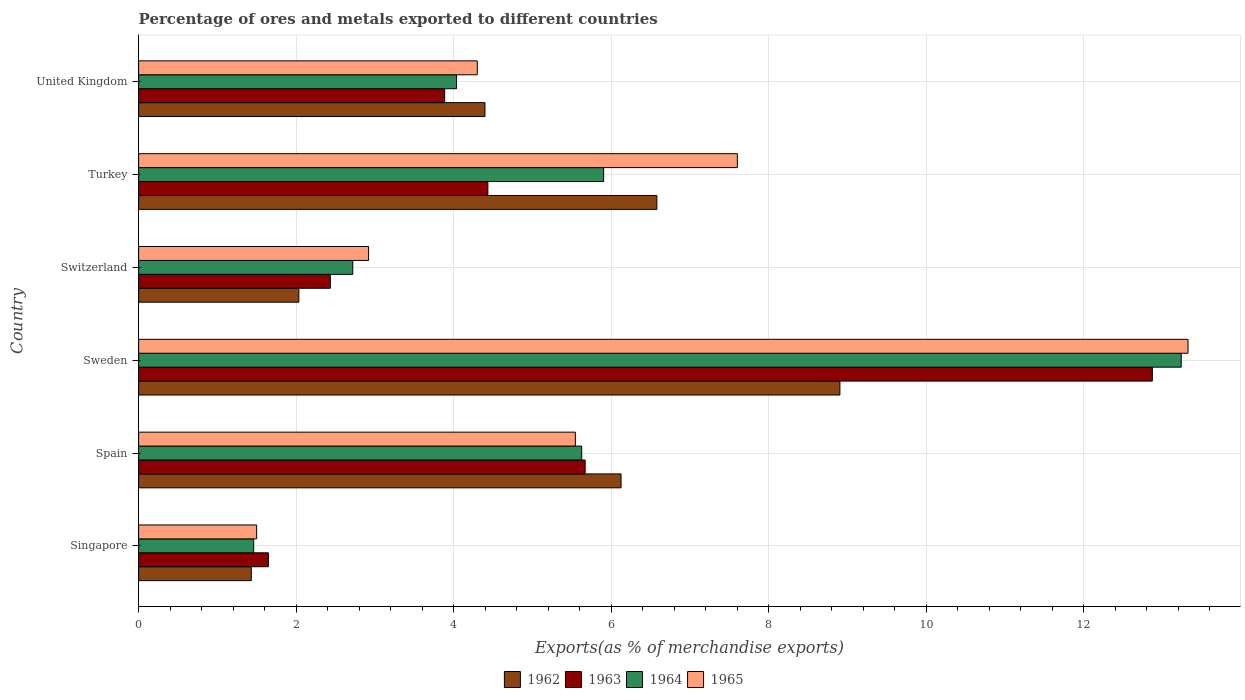How many different coloured bars are there?
Offer a terse response. 4. Are the number of bars per tick equal to the number of legend labels?
Provide a short and direct response. Yes. Are the number of bars on each tick of the Y-axis equal?
Your response must be concise. Yes. How many bars are there on the 1st tick from the top?
Keep it short and to the point. 4. How many bars are there on the 2nd tick from the bottom?
Provide a short and direct response. 4. What is the label of the 3rd group of bars from the top?
Ensure brevity in your answer.  Switzerland. In how many cases, is the number of bars for a given country not equal to the number of legend labels?
Give a very brief answer. 0. What is the percentage of exports to different countries in 1965 in Singapore?
Provide a short and direct response. 1.5. Across all countries, what is the maximum percentage of exports to different countries in 1964?
Provide a short and direct response. 13.24. Across all countries, what is the minimum percentage of exports to different countries in 1965?
Offer a very short reply. 1.5. In which country was the percentage of exports to different countries in 1963 maximum?
Provide a short and direct response. Sweden. In which country was the percentage of exports to different countries in 1963 minimum?
Offer a terse response. Singapore. What is the total percentage of exports to different countries in 1965 in the graph?
Give a very brief answer. 35.19. What is the difference between the percentage of exports to different countries in 1962 in Sweden and that in Turkey?
Your response must be concise. 2.32. What is the difference between the percentage of exports to different countries in 1962 in Sweden and the percentage of exports to different countries in 1963 in Spain?
Provide a short and direct response. 3.23. What is the average percentage of exports to different countries in 1965 per country?
Offer a very short reply. 5.86. What is the difference between the percentage of exports to different countries in 1965 and percentage of exports to different countries in 1962 in Spain?
Your answer should be very brief. -0.58. In how many countries, is the percentage of exports to different countries in 1963 greater than 2.4 %?
Your answer should be very brief. 5. What is the ratio of the percentage of exports to different countries in 1962 in Spain to that in Sweden?
Provide a short and direct response. 0.69. Is the percentage of exports to different countries in 1964 in Sweden less than that in Turkey?
Keep it short and to the point. No. What is the difference between the highest and the second highest percentage of exports to different countries in 1964?
Make the answer very short. 7.33. What is the difference between the highest and the lowest percentage of exports to different countries in 1965?
Provide a short and direct response. 11.83. In how many countries, is the percentage of exports to different countries in 1964 greater than the average percentage of exports to different countries in 1964 taken over all countries?
Your answer should be compact. 3. Is the sum of the percentage of exports to different countries in 1963 in Sweden and United Kingdom greater than the maximum percentage of exports to different countries in 1965 across all countries?
Give a very brief answer. Yes. Is it the case that in every country, the sum of the percentage of exports to different countries in 1965 and percentage of exports to different countries in 1963 is greater than the sum of percentage of exports to different countries in 1964 and percentage of exports to different countries in 1962?
Offer a terse response. No. What does the 3rd bar from the top in Singapore represents?
Keep it short and to the point. 1963. How many bars are there?
Keep it short and to the point. 24. Are all the bars in the graph horizontal?
Provide a succinct answer. Yes. How many countries are there in the graph?
Ensure brevity in your answer.  6. Does the graph contain any zero values?
Ensure brevity in your answer.  No. Does the graph contain grids?
Your answer should be compact. Yes. What is the title of the graph?
Your answer should be very brief. Percentage of ores and metals exported to different countries. What is the label or title of the X-axis?
Give a very brief answer. Exports(as % of merchandise exports). What is the label or title of the Y-axis?
Provide a short and direct response. Country. What is the Exports(as % of merchandise exports) of 1962 in Singapore?
Provide a short and direct response. 1.43. What is the Exports(as % of merchandise exports) in 1963 in Singapore?
Your answer should be very brief. 1.65. What is the Exports(as % of merchandise exports) of 1964 in Singapore?
Make the answer very short. 1.46. What is the Exports(as % of merchandise exports) of 1965 in Singapore?
Your response must be concise. 1.5. What is the Exports(as % of merchandise exports) in 1962 in Spain?
Ensure brevity in your answer.  6.13. What is the Exports(as % of merchandise exports) of 1963 in Spain?
Provide a succinct answer. 5.67. What is the Exports(as % of merchandise exports) of 1964 in Spain?
Keep it short and to the point. 5.63. What is the Exports(as % of merchandise exports) of 1965 in Spain?
Ensure brevity in your answer.  5.55. What is the Exports(as % of merchandise exports) in 1962 in Sweden?
Your answer should be compact. 8.9. What is the Exports(as % of merchandise exports) in 1963 in Sweden?
Offer a terse response. 12.87. What is the Exports(as % of merchandise exports) in 1964 in Sweden?
Your answer should be very brief. 13.24. What is the Exports(as % of merchandise exports) of 1965 in Sweden?
Your answer should be compact. 13.32. What is the Exports(as % of merchandise exports) of 1962 in Switzerland?
Give a very brief answer. 2.03. What is the Exports(as % of merchandise exports) of 1963 in Switzerland?
Your answer should be very brief. 2.43. What is the Exports(as % of merchandise exports) in 1964 in Switzerland?
Provide a succinct answer. 2.72. What is the Exports(as % of merchandise exports) of 1965 in Switzerland?
Provide a succinct answer. 2.92. What is the Exports(as % of merchandise exports) in 1962 in Turkey?
Give a very brief answer. 6.58. What is the Exports(as % of merchandise exports) in 1963 in Turkey?
Provide a succinct answer. 4.43. What is the Exports(as % of merchandise exports) in 1964 in Turkey?
Your answer should be very brief. 5.9. What is the Exports(as % of merchandise exports) of 1965 in Turkey?
Ensure brevity in your answer.  7.6. What is the Exports(as % of merchandise exports) of 1962 in United Kingdom?
Provide a succinct answer. 4.4. What is the Exports(as % of merchandise exports) in 1963 in United Kingdom?
Your response must be concise. 3.89. What is the Exports(as % of merchandise exports) of 1964 in United Kingdom?
Your response must be concise. 4.04. What is the Exports(as % of merchandise exports) in 1965 in United Kingdom?
Give a very brief answer. 4.3. Across all countries, what is the maximum Exports(as % of merchandise exports) in 1962?
Your response must be concise. 8.9. Across all countries, what is the maximum Exports(as % of merchandise exports) in 1963?
Ensure brevity in your answer.  12.87. Across all countries, what is the maximum Exports(as % of merchandise exports) in 1964?
Keep it short and to the point. 13.24. Across all countries, what is the maximum Exports(as % of merchandise exports) in 1965?
Give a very brief answer. 13.32. Across all countries, what is the minimum Exports(as % of merchandise exports) of 1962?
Make the answer very short. 1.43. Across all countries, what is the minimum Exports(as % of merchandise exports) in 1963?
Your answer should be compact. 1.65. Across all countries, what is the minimum Exports(as % of merchandise exports) in 1964?
Your answer should be compact. 1.46. Across all countries, what is the minimum Exports(as % of merchandise exports) in 1965?
Ensure brevity in your answer.  1.5. What is the total Exports(as % of merchandise exports) in 1962 in the graph?
Give a very brief answer. 29.47. What is the total Exports(as % of merchandise exports) of 1963 in the graph?
Keep it short and to the point. 30.94. What is the total Exports(as % of merchandise exports) of 1964 in the graph?
Your response must be concise. 32.98. What is the total Exports(as % of merchandise exports) in 1965 in the graph?
Your answer should be very brief. 35.19. What is the difference between the Exports(as % of merchandise exports) of 1962 in Singapore and that in Spain?
Keep it short and to the point. -4.69. What is the difference between the Exports(as % of merchandise exports) in 1963 in Singapore and that in Spain?
Ensure brevity in your answer.  -4.02. What is the difference between the Exports(as % of merchandise exports) in 1964 in Singapore and that in Spain?
Provide a succinct answer. -4.16. What is the difference between the Exports(as % of merchandise exports) in 1965 in Singapore and that in Spain?
Give a very brief answer. -4.05. What is the difference between the Exports(as % of merchandise exports) in 1962 in Singapore and that in Sweden?
Your response must be concise. -7.47. What is the difference between the Exports(as % of merchandise exports) of 1963 in Singapore and that in Sweden?
Give a very brief answer. -11.22. What is the difference between the Exports(as % of merchandise exports) of 1964 in Singapore and that in Sweden?
Offer a very short reply. -11.78. What is the difference between the Exports(as % of merchandise exports) of 1965 in Singapore and that in Sweden?
Make the answer very short. -11.83. What is the difference between the Exports(as % of merchandise exports) of 1962 in Singapore and that in Switzerland?
Make the answer very short. -0.6. What is the difference between the Exports(as % of merchandise exports) of 1963 in Singapore and that in Switzerland?
Your answer should be compact. -0.79. What is the difference between the Exports(as % of merchandise exports) of 1964 in Singapore and that in Switzerland?
Make the answer very short. -1.26. What is the difference between the Exports(as % of merchandise exports) of 1965 in Singapore and that in Switzerland?
Your answer should be very brief. -1.42. What is the difference between the Exports(as % of merchandise exports) of 1962 in Singapore and that in Turkey?
Offer a terse response. -5.15. What is the difference between the Exports(as % of merchandise exports) of 1963 in Singapore and that in Turkey?
Make the answer very short. -2.79. What is the difference between the Exports(as % of merchandise exports) of 1964 in Singapore and that in Turkey?
Your answer should be compact. -4.44. What is the difference between the Exports(as % of merchandise exports) of 1965 in Singapore and that in Turkey?
Provide a succinct answer. -6.1. What is the difference between the Exports(as % of merchandise exports) of 1962 in Singapore and that in United Kingdom?
Make the answer very short. -2.97. What is the difference between the Exports(as % of merchandise exports) of 1963 in Singapore and that in United Kingdom?
Make the answer very short. -2.24. What is the difference between the Exports(as % of merchandise exports) of 1964 in Singapore and that in United Kingdom?
Make the answer very short. -2.58. What is the difference between the Exports(as % of merchandise exports) in 1965 in Singapore and that in United Kingdom?
Offer a very short reply. -2.8. What is the difference between the Exports(as % of merchandise exports) in 1962 in Spain and that in Sweden?
Keep it short and to the point. -2.78. What is the difference between the Exports(as % of merchandise exports) in 1963 in Spain and that in Sweden?
Your response must be concise. -7.2. What is the difference between the Exports(as % of merchandise exports) of 1964 in Spain and that in Sweden?
Keep it short and to the point. -7.61. What is the difference between the Exports(as % of merchandise exports) in 1965 in Spain and that in Sweden?
Keep it short and to the point. -7.78. What is the difference between the Exports(as % of merchandise exports) of 1962 in Spain and that in Switzerland?
Make the answer very short. 4.09. What is the difference between the Exports(as % of merchandise exports) in 1963 in Spain and that in Switzerland?
Ensure brevity in your answer.  3.24. What is the difference between the Exports(as % of merchandise exports) in 1964 in Spain and that in Switzerland?
Offer a terse response. 2.91. What is the difference between the Exports(as % of merchandise exports) of 1965 in Spain and that in Switzerland?
Offer a very short reply. 2.63. What is the difference between the Exports(as % of merchandise exports) of 1962 in Spain and that in Turkey?
Give a very brief answer. -0.46. What is the difference between the Exports(as % of merchandise exports) of 1963 in Spain and that in Turkey?
Keep it short and to the point. 1.23. What is the difference between the Exports(as % of merchandise exports) of 1964 in Spain and that in Turkey?
Your answer should be very brief. -0.28. What is the difference between the Exports(as % of merchandise exports) in 1965 in Spain and that in Turkey?
Your answer should be compact. -2.06. What is the difference between the Exports(as % of merchandise exports) of 1962 in Spain and that in United Kingdom?
Keep it short and to the point. 1.73. What is the difference between the Exports(as % of merchandise exports) in 1963 in Spain and that in United Kingdom?
Your answer should be compact. 1.78. What is the difference between the Exports(as % of merchandise exports) in 1964 in Spain and that in United Kingdom?
Ensure brevity in your answer.  1.59. What is the difference between the Exports(as % of merchandise exports) of 1965 in Spain and that in United Kingdom?
Offer a terse response. 1.25. What is the difference between the Exports(as % of merchandise exports) in 1962 in Sweden and that in Switzerland?
Provide a short and direct response. 6.87. What is the difference between the Exports(as % of merchandise exports) of 1963 in Sweden and that in Switzerland?
Give a very brief answer. 10.44. What is the difference between the Exports(as % of merchandise exports) in 1964 in Sweden and that in Switzerland?
Give a very brief answer. 10.52. What is the difference between the Exports(as % of merchandise exports) in 1965 in Sweden and that in Switzerland?
Ensure brevity in your answer.  10.4. What is the difference between the Exports(as % of merchandise exports) of 1962 in Sweden and that in Turkey?
Offer a terse response. 2.32. What is the difference between the Exports(as % of merchandise exports) in 1963 in Sweden and that in Turkey?
Provide a short and direct response. 8.44. What is the difference between the Exports(as % of merchandise exports) in 1964 in Sweden and that in Turkey?
Offer a terse response. 7.33. What is the difference between the Exports(as % of merchandise exports) in 1965 in Sweden and that in Turkey?
Offer a very short reply. 5.72. What is the difference between the Exports(as % of merchandise exports) in 1962 in Sweden and that in United Kingdom?
Offer a very short reply. 4.51. What is the difference between the Exports(as % of merchandise exports) of 1963 in Sweden and that in United Kingdom?
Your answer should be very brief. 8.99. What is the difference between the Exports(as % of merchandise exports) in 1964 in Sweden and that in United Kingdom?
Offer a very short reply. 9.2. What is the difference between the Exports(as % of merchandise exports) of 1965 in Sweden and that in United Kingdom?
Offer a very short reply. 9.02. What is the difference between the Exports(as % of merchandise exports) of 1962 in Switzerland and that in Turkey?
Ensure brevity in your answer.  -4.55. What is the difference between the Exports(as % of merchandise exports) in 1963 in Switzerland and that in Turkey?
Offer a terse response. -2. What is the difference between the Exports(as % of merchandise exports) of 1964 in Switzerland and that in Turkey?
Make the answer very short. -3.19. What is the difference between the Exports(as % of merchandise exports) of 1965 in Switzerland and that in Turkey?
Your response must be concise. -4.68. What is the difference between the Exports(as % of merchandise exports) of 1962 in Switzerland and that in United Kingdom?
Provide a succinct answer. -2.36. What is the difference between the Exports(as % of merchandise exports) in 1963 in Switzerland and that in United Kingdom?
Offer a very short reply. -1.45. What is the difference between the Exports(as % of merchandise exports) in 1964 in Switzerland and that in United Kingdom?
Make the answer very short. -1.32. What is the difference between the Exports(as % of merchandise exports) of 1965 in Switzerland and that in United Kingdom?
Provide a short and direct response. -1.38. What is the difference between the Exports(as % of merchandise exports) in 1962 in Turkey and that in United Kingdom?
Offer a terse response. 2.18. What is the difference between the Exports(as % of merchandise exports) of 1963 in Turkey and that in United Kingdom?
Your answer should be compact. 0.55. What is the difference between the Exports(as % of merchandise exports) of 1964 in Turkey and that in United Kingdom?
Give a very brief answer. 1.87. What is the difference between the Exports(as % of merchandise exports) in 1965 in Turkey and that in United Kingdom?
Offer a terse response. 3.3. What is the difference between the Exports(as % of merchandise exports) of 1962 in Singapore and the Exports(as % of merchandise exports) of 1963 in Spain?
Offer a very short reply. -4.24. What is the difference between the Exports(as % of merchandise exports) of 1962 in Singapore and the Exports(as % of merchandise exports) of 1964 in Spain?
Ensure brevity in your answer.  -4.2. What is the difference between the Exports(as % of merchandise exports) of 1962 in Singapore and the Exports(as % of merchandise exports) of 1965 in Spain?
Keep it short and to the point. -4.11. What is the difference between the Exports(as % of merchandise exports) of 1963 in Singapore and the Exports(as % of merchandise exports) of 1964 in Spain?
Provide a succinct answer. -3.98. What is the difference between the Exports(as % of merchandise exports) of 1963 in Singapore and the Exports(as % of merchandise exports) of 1965 in Spain?
Offer a terse response. -3.9. What is the difference between the Exports(as % of merchandise exports) of 1964 in Singapore and the Exports(as % of merchandise exports) of 1965 in Spain?
Your answer should be very brief. -4.08. What is the difference between the Exports(as % of merchandise exports) in 1962 in Singapore and the Exports(as % of merchandise exports) in 1963 in Sweden?
Provide a short and direct response. -11.44. What is the difference between the Exports(as % of merchandise exports) in 1962 in Singapore and the Exports(as % of merchandise exports) in 1964 in Sweden?
Provide a succinct answer. -11.81. What is the difference between the Exports(as % of merchandise exports) in 1962 in Singapore and the Exports(as % of merchandise exports) in 1965 in Sweden?
Ensure brevity in your answer.  -11.89. What is the difference between the Exports(as % of merchandise exports) of 1963 in Singapore and the Exports(as % of merchandise exports) of 1964 in Sweden?
Ensure brevity in your answer.  -11.59. What is the difference between the Exports(as % of merchandise exports) of 1963 in Singapore and the Exports(as % of merchandise exports) of 1965 in Sweden?
Your answer should be very brief. -11.68. What is the difference between the Exports(as % of merchandise exports) of 1964 in Singapore and the Exports(as % of merchandise exports) of 1965 in Sweden?
Your answer should be compact. -11.86. What is the difference between the Exports(as % of merchandise exports) in 1962 in Singapore and the Exports(as % of merchandise exports) in 1963 in Switzerland?
Offer a terse response. -1. What is the difference between the Exports(as % of merchandise exports) of 1962 in Singapore and the Exports(as % of merchandise exports) of 1964 in Switzerland?
Offer a terse response. -1.29. What is the difference between the Exports(as % of merchandise exports) of 1962 in Singapore and the Exports(as % of merchandise exports) of 1965 in Switzerland?
Provide a succinct answer. -1.49. What is the difference between the Exports(as % of merchandise exports) of 1963 in Singapore and the Exports(as % of merchandise exports) of 1964 in Switzerland?
Your response must be concise. -1.07. What is the difference between the Exports(as % of merchandise exports) of 1963 in Singapore and the Exports(as % of merchandise exports) of 1965 in Switzerland?
Offer a very short reply. -1.27. What is the difference between the Exports(as % of merchandise exports) of 1964 in Singapore and the Exports(as % of merchandise exports) of 1965 in Switzerland?
Provide a succinct answer. -1.46. What is the difference between the Exports(as % of merchandise exports) of 1962 in Singapore and the Exports(as % of merchandise exports) of 1963 in Turkey?
Offer a terse response. -3. What is the difference between the Exports(as % of merchandise exports) of 1962 in Singapore and the Exports(as % of merchandise exports) of 1964 in Turkey?
Provide a succinct answer. -4.47. What is the difference between the Exports(as % of merchandise exports) of 1962 in Singapore and the Exports(as % of merchandise exports) of 1965 in Turkey?
Provide a short and direct response. -6.17. What is the difference between the Exports(as % of merchandise exports) of 1963 in Singapore and the Exports(as % of merchandise exports) of 1964 in Turkey?
Provide a succinct answer. -4.26. What is the difference between the Exports(as % of merchandise exports) in 1963 in Singapore and the Exports(as % of merchandise exports) in 1965 in Turkey?
Offer a very short reply. -5.95. What is the difference between the Exports(as % of merchandise exports) of 1964 in Singapore and the Exports(as % of merchandise exports) of 1965 in Turkey?
Provide a succinct answer. -6.14. What is the difference between the Exports(as % of merchandise exports) of 1962 in Singapore and the Exports(as % of merchandise exports) of 1963 in United Kingdom?
Your answer should be compact. -2.46. What is the difference between the Exports(as % of merchandise exports) in 1962 in Singapore and the Exports(as % of merchandise exports) in 1964 in United Kingdom?
Give a very brief answer. -2.61. What is the difference between the Exports(as % of merchandise exports) of 1962 in Singapore and the Exports(as % of merchandise exports) of 1965 in United Kingdom?
Provide a succinct answer. -2.87. What is the difference between the Exports(as % of merchandise exports) of 1963 in Singapore and the Exports(as % of merchandise exports) of 1964 in United Kingdom?
Offer a very short reply. -2.39. What is the difference between the Exports(as % of merchandise exports) of 1963 in Singapore and the Exports(as % of merchandise exports) of 1965 in United Kingdom?
Provide a succinct answer. -2.65. What is the difference between the Exports(as % of merchandise exports) of 1964 in Singapore and the Exports(as % of merchandise exports) of 1965 in United Kingdom?
Keep it short and to the point. -2.84. What is the difference between the Exports(as % of merchandise exports) of 1962 in Spain and the Exports(as % of merchandise exports) of 1963 in Sweden?
Offer a terse response. -6.75. What is the difference between the Exports(as % of merchandise exports) in 1962 in Spain and the Exports(as % of merchandise exports) in 1964 in Sweden?
Keep it short and to the point. -7.11. What is the difference between the Exports(as % of merchandise exports) in 1962 in Spain and the Exports(as % of merchandise exports) in 1965 in Sweden?
Keep it short and to the point. -7.2. What is the difference between the Exports(as % of merchandise exports) of 1963 in Spain and the Exports(as % of merchandise exports) of 1964 in Sweden?
Provide a succinct answer. -7.57. What is the difference between the Exports(as % of merchandise exports) in 1963 in Spain and the Exports(as % of merchandise exports) in 1965 in Sweden?
Ensure brevity in your answer.  -7.65. What is the difference between the Exports(as % of merchandise exports) in 1964 in Spain and the Exports(as % of merchandise exports) in 1965 in Sweden?
Provide a short and direct response. -7.7. What is the difference between the Exports(as % of merchandise exports) of 1962 in Spain and the Exports(as % of merchandise exports) of 1963 in Switzerland?
Make the answer very short. 3.69. What is the difference between the Exports(as % of merchandise exports) in 1962 in Spain and the Exports(as % of merchandise exports) in 1964 in Switzerland?
Your answer should be compact. 3.41. What is the difference between the Exports(as % of merchandise exports) of 1962 in Spain and the Exports(as % of merchandise exports) of 1965 in Switzerland?
Provide a short and direct response. 3.21. What is the difference between the Exports(as % of merchandise exports) of 1963 in Spain and the Exports(as % of merchandise exports) of 1964 in Switzerland?
Your answer should be compact. 2.95. What is the difference between the Exports(as % of merchandise exports) in 1963 in Spain and the Exports(as % of merchandise exports) in 1965 in Switzerland?
Provide a succinct answer. 2.75. What is the difference between the Exports(as % of merchandise exports) of 1964 in Spain and the Exports(as % of merchandise exports) of 1965 in Switzerland?
Offer a terse response. 2.71. What is the difference between the Exports(as % of merchandise exports) of 1962 in Spain and the Exports(as % of merchandise exports) of 1963 in Turkey?
Your answer should be compact. 1.69. What is the difference between the Exports(as % of merchandise exports) of 1962 in Spain and the Exports(as % of merchandise exports) of 1964 in Turkey?
Provide a succinct answer. 0.22. What is the difference between the Exports(as % of merchandise exports) in 1962 in Spain and the Exports(as % of merchandise exports) in 1965 in Turkey?
Ensure brevity in your answer.  -1.48. What is the difference between the Exports(as % of merchandise exports) in 1963 in Spain and the Exports(as % of merchandise exports) in 1964 in Turkey?
Provide a succinct answer. -0.23. What is the difference between the Exports(as % of merchandise exports) in 1963 in Spain and the Exports(as % of merchandise exports) in 1965 in Turkey?
Give a very brief answer. -1.93. What is the difference between the Exports(as % of merchandise exports) of 1964 in Spain and the Exports(as % of merchandise exports) of 1965 in Turkey?
Provide a succinct answer. -1.98. What is the difference between the Exports(as % of merchandise exports) in 1962 in Spain and the Exports(as % of merchandise exports) in 1963 in United Kingdom?
Your answer should be very brief. 2.24. What is the difference between the Exports(as % of merchandise exports) of 1962 in Spain and the Exports(as % of merchandise exports) of 1964 in United Kingdom?
Ensure brevity in your answer.  2.09. What is the difference between the Exports(as % of merchandise exports) of 1962 in Spain and the Exports(as % of merchandise exports) of 1965 in United Kingdom?
Offer a very short reply. 1.83. What is the difference between the Exports(as % of merchandise exports) in 1963 in Spain and the Exports(as % of merchandise exports) in 1964 in United Kingdom?
Your answer should be compact. 1.63. What is the difference between the Exports(as % of merchandise exports) in 1963 in Spain and the Exports(as % of merchandise exports) in 1965 in United Kingdom?
Provide a succinct answer. 1.37. What is the difference between the Exports(as % of merchandise exports) of 1964 in Spain and the Exports(as % of merchandise exports) of 1965 in United Kingdom?
Your answer should be very brief. 1.33. What is the difference between the Exports(as % of merchandise exports) in 1962 in Sweden and the Exports(as % of merchandise exports) in 1963 in Switzerland?
Your answer should be very brief. 6.47. What is the difference between the Exports(as % of merchandise exports) in 1962 in Sweden and the Exports(as % of merchandise exports) in 1964 in Switzerland?
Offer a very short reply. 6.18. What is the difference between the Exports(as % of merchandise exports) of 1962 in Sweden and the Exports(as % of merchandise exports) of 1965 in Switzerland?
Make the answer very short. 5.98. What is the difference between the Exports(as % of merchandise exports) in 1963 in Sweden and the Exports(as % of merchandise exports) in 1964 in Switzerland?
Offer a very short reply. 10.15. What is the difference between the Exports(as % of merchandise exports) of 1963 in Sweden and the Exports(as % of merchandise exports) of 1965 in Switzerland?
Offer a terse response. 9.95. What is the difference between the Exports(as % of merchandise exports) in 1964 in Sweden and the Exports(as % of merchandise exports) in 1965 in Switzerland?
Offer a terse response. 10.32. What is the difference between the Exports(as % of merchandise exports) of 1962 in Sweden and the Exports(as % of merchandise exports) of 1963 in Turkey?
Keep it short and to the point. 4.47. What is the difference between the Exports(as % of merchandise exports) of 1962 in Sweden and the Exports(as % of merchandise exports) of 1964 in Turkey?
Your answer should be compact. 3. What is the difference between the Exports(as % of merchandise exports) of 1962 in Sweden and the Exports(as % of merchandise exports) of 1965 in Turkey?
Provide a succinct answer. 1.3. What is the difference between the Exports(as % of merchandise exports) of 1963 in Sweden and the Exports(as % of merchandise exports) of 1964 in Turkey?
Give a very brief answer. 6.97. What is the difference between the Exports(as % of merchandise exports) in 1963 in Sweden and the Exports(as % of merchandise exports) in 1965 in Turkey?
Ensure brevity in your answer.  5.27. What is the difference between the Exports(as % of merchandise exports) of 1964 in Sweden and the Exports(as % of merchandise exports) of 1965 in Turkey?
Offer a very short reply. 5.64. What is the difference between the Exports(as % of merchandise exports) in 1962 in Sweden and the Exports(as % of merchandise exports) in 1963 in United Kingdom?
Offer a very short reply. 5.02. What is the difference between the Exports(as % of merchandise exports) in 1962 in Sweden and the Exports(as % of merchandise exports) in 1964 in United Kingdom?
Your answer should be very brief. 4.87. What is the difference between the Exports(as % of merchandise exports) of 1962 in Sweden and the Exports(as % of merchandise exports) of 1965 in United Kingdom?
Your response must be concise. 4.6. What is the difference between the Exports(as % of merchandise exports) of 1963 in Sweden and the Exports(as % of merchandise exports) of 1964 in United Kingdom?
Offer a very short reply. 8.83. What is the difference between the Exports(as % of merchandise exports) of 1963 in Sweden and the Exports(as % of merchandise exports) of 1965 in United Kingdom?
Provide a short and direct response. 8.57. What is the difference between the Exports(as % of merchandise exports) of 1964 in Sweden and the Exports(as % of merchandise exports) of 1965 in United Kingdom?
Offer a terse response. 8.94. What is the difference between the Exports(as % of merchandise exports) in 1962 in Switzerland and the Exports(as % of merchandise exports) in 1963 in Turkey?
Your response must be concise. -2.4. What is the difference between the Exports(as % of merchandise exports) in 1962 in Switzerland and the Exports(as % of merchandise exports) in 1964 in Turkey?
Offer a terse response. -3.87. What is the difference between the Exports(as % of merchandise exports) in 1962 in Switzerland and the Exports(as % of merchandise exports) in 1965 in Turkey?
Ensure brevity in your answer.  -5.57. What is the difference between the Exports(as % of merchandise exports) in 1963 in Switzerland and the Exports(as % of merchandise exports) in 1964 in Turkey?
Provide a short and direct response. -3.47. What is the difference between the Exports(as % of merchandise exports) in 1963 in Switzerland and the Exports(as % of merchandise exports) in 1965 in Turkey?
Provide a short and direct response. -5.17. What is the difference between the Exports(as % of merchandise exports) of 1964 in Switzerland and the Exports(as % of merchandise exports) of 1965 in Turkey?
Make the answer very short. -4.88. What is the difference between the Exports(as % of merchandise exports) of 1962 in Switzerland and the Exports(as % of merchandise exports) of 1963 in United Kingdom?
Your response must be concise. -1.85. What is the difference between the Exports(as % of merchandise exports) in 1962 in Switzerland and the Exports(as % of merchandise exports) in 1964 in United Kingdom?
Make the answer very short. -2. What is the difference between the Exports(as % of merchandise exports) of 1962 in Switzerland and the Exports(as % of merchandise exports) of 1965 in United Kingdom?
Provide a succinct answer. -2.27. What is the difference between the Exports(as % of merchandise exports) of 1963 in Switzerland and the Exports(as % of merchandise exports) of 1964 in United Kingdom?
Offer a terse response. -1.6. What is the difference between the Exports(as % of merchandise exports) in 1963 in Switzerland and the Exports(as % of merchandise exports) in 1965 in United Kingdom?
Ensure brevity in your answer.  -1.87. What is the difference between the Exports(as % of merchandise exports) in 1964 in Switzerland and the Exports(as % of merchandise exports) in 1965 in United Kingdom?
Your answer should be very brief. -1.58. What is the difference between the Exports(as % of merchandise exports) of 1962 in Turkey and the Exports(as % of merchandise exports) of 1963 in United Kingdom?
Your answer should be compact. 2.69. What is the difference between the Exports(as % of merchandise exports) in 1962 in Turkey and the Exports(as % of merchandise exports) in 1964 in United Kingdom?
Your answer should be very brief. 2.54. What is the difference between the Exports(as % of merchandise exports) in 1962 in Turkey and the Exports(as % of merchandise exports) in 1965 in United Kingdom?
Offer a terse response. 2.28. What is the difference between the Exports(as % of merchandise exports) of 1963 in Turkey and the Exports(as % of merchandise exports) of 1964 in United Kingdom?
Your answer should be very brief. 0.4. What is the difference between the Exports(as % of merchandise exports) in 1963 in Turkey and the Exports(as % of merchandise exports) in 1965 in United Kingdom?
Your response must be concise. 0.13. What is the difference between the Exports(as % of merchandise exports) in 1964 in Turkey and the Exports(as % of merchandise exports) in 1965 in United Kingdom?
Offer a terse response. 1.6. What is the average Exports(as % of merchandise exports) in 1962 per country?
Give a very brief answer. 4.91. What is the average Exports(as % of merchandise exports) of 1963 per country?
Keep it short and to the point. 5.16. What is the average Exports(as % of merchandise exports) of 1964 per country?
Ensure brevity in your answer.  5.5. What is the average Exports(as % of merchandise exports) of 1965 per country?
Your answer should be compact. 5.86. What is the difference between the Exports(as % of merchandise exports) in 1962 and Exports(as % of merchandise exports) in 1963 in Singapore?
Provide a short and direct response. -0.22. What is the difference between the Exports(as % of merchandise exports) of 1962 and Exports(as % of merchandise exports) of 1964 in Singapore?
Your response must be concise. -0.03. What is the difference between the Exports(as % of merchandise exports) in 1962 and Exports(as % of merchandise exports) in 1965 in Singapore?
Give a very brief answer. -0.07. What is the difference between the Exports(as % of merchandise exports) of 1963 and Exports(as % of merchandise exports) of 1964 in Singapore?
Provide a succinct answer. 0.19. What is the difference between the Exports(as % of merchandise exports) of 1963 and Exports(as % of merchandise exports) of 1965 in Singapore?
Offer a terse response. 0.15. What is the difference between the Exports(as % of merchandise exports) in 1964 and Exports(as % of merchandise exports) in 1965 in Singapore?
Offer a very short reply. -0.04. What is the difference between the Exports(as % of merchandise exports) in 1962 and Exports(as % of merchandise exports) in 1963 in Spain?
Offer a terse response. 0.46. What is the difference between the Exports(as % of merchandise exports) in 1962 and Exports(as % of merchandise exports) in 1964 in Spain?
Offer a very short reply. 0.5. What is the difference between the Exports(as % of merchandise exports) in 1962 and Exports(as % of merchandise exports) in 1965 in Spain?
Offer a terse response. 0.58. What is the difference between the Exports(as % of merchandise exports) of 1963 and Exports(as % of merchandise exports) of 1964 in Spain?
Ensure brevity in your answer.  0.04. What is the difference between the Exports(as % of merchandise exports) of 1963 and Exports(as % of merchandise exports) of 1965 in Spain?
Your answer should be very brief. 0.12. What is the difference between the Exports(as % of merchandise exports) of 1964 and Exports(as % of merchandise exports) of 1965 in Spain?
Your response must be concise. 0.08. What is the difference between the Exports(as % of merchandise exports) in 1962 and Exports(as % of merchandise exports) in 1963 in Sweden?
Keep it short and to the point. -3.97. What is the difference between the Exports(as % of merchandise exports) in 1962 and Exports(as % of merchandise exports) in 1964 in Sweden?
Make the answer very short. -4.33. What is the difference between the Exports(as % of merchandise exports) in 1962 and Exports(as % of merchandise exports) in 1965 in Sweden?
Give a very brief answer. -4.42. What is the difference between the Exports(as % of merchandise exports) in 1963 and Exports(as % of merchandise exports) in 1964 in Sweden?
Provide a succinct answer. -0.37. What is the difference between the Exports(as % of merchandise exports) of 1963 and Exports(as % of merchandise exports) of 1965 in Sweden?
Ensure brevity in your answer.  -0.45. What is the difference between the Exports(as % of merchandise exports) of 1964 and Exports(as % of merchandise exports) of 1965 in Sweden?
Give a very brief answer. -0.09. What is the difference between the Exports(as % of merchandise exports) of 1962 and Exports(as % of merchandise exports) of 1963 in Switzerland?
Make the answer very short. -0.4. What is the difference between the Exports(as % of merchandise exports) of 1962 and Exports(as % of merchandise exports) of 1964 in Switzerland?
Offer a terse response. -0.68. What is the difference between the Exports(as % of merchandise exports) in 1962 and Exports(as % of merchandise exports) in 1965 in Switzerland?
Your answer should be very brief. -0.89. What is the difference between the Exports(as % of merchandise exports) of 1963 and Exports(as % of merchandise exports) of 1964 in Switzerland?
Provide a succinct answer. -0.29. What is the difference between the Exports(as % of merchandise exports) of 1963 and Exports(as % of merchandise exports) of 1965 in Switzerland?
Give a very brief answer. -0.49. What is the difference between the Exports(as % of merchandise exports) in 1964 and Exports(as % of merchandise exports) in 1965 in Switzerland?
Your answer should be very brief. -0.2. What is the difference between the Exports(as % of merchandise exports) in 1962 and Exports(as % of merchandise exports) in 1963 in Turkey?
Your answer should be compact. 2.15. What is the difference between the Exports(as % of merchandise exports) of 1962 and Exports(as % of merchandise exports) of 1964 in Turkey?
Give a very brief answer. 0.68. What is the difference between the Exports(as % of merchandise exports) in 1962 and Exports(as % of merchandise exports) in 1965 in Turkey?
Your answer should be compact. -1.02. What is the difference between the Exports(as % of merchandise exports) of 1963 and Exports(as % of merchandise exports) of 1964 in Turkey?
Provide a short and direct response. -1.47. What is the difference between the Exports(as % of merchandise exports) of 1963 and Exports(as % of merchandise exports) of 1965 in Turkey?
Offer a very short reply. -3.17. What is the difference between the Exports(as % of merchandise exports) of 1964 and Exports(as % of merchandise exports) of 1965 in Turkey?
Provide a short and direct response. -1.7. What is the difference between the Exports(as % of merchandise exports) of 1962 and Exports(as % of merchandise exports) of 1963 in United Kingdom?
Ensure brevity in your answer.  0.51. What is the difference between the Exports(as % of merchandise exports) of 1962 and Exports(as % of merchandise exports) of 1964 in United Kingdom?
Give a very brief answer. 0.36. What is the difference between the Exports(as % of merchandise exports) in 1962 and Exports(as % of merchandise exports) in 1965 in United Kingdom?
Give a very brief answer. 0.1. What is the difference between the Exports(as % of merchandise exports) of 1963 and Exports(as % of merchandise exports) of 1964 in United Kingdom?
Give a very brief answer. -0.15. What is the difference between the Exports(as % of merchandise exports) in 1963 and Exports(as % of merchandise exports) in 1965 in United Kingdom?
Ensure brevity in your answer.  -0.41. What is the difference between the Exports(as % of merchandise exports) in 1964 and Exports(as % of merchandise exports) in 1965 in United Kingdom?
Give a very brief answer. -0.26. What is the ratio of the Exports(as % of merchandise exports) of 1962 in Singapore to that in Spain?
Provide a short and direct response. 0.23. What is the ratio of the Exports(as % of merchandise exports) of 1963 in Singapore to that in Spain?
Provide a succinct answer. 0.29. What is the ratio of the Exports(as % of merchandise exports) in 1964 in Singapore to that in Spain?
Make the answer very short. 0.26. What is the ratio of the Exports(as % of merchandise exports) of 1965 in Singapore to that in Spain?
Offer a very short reply. 0.27. What is the ratio of the Exports(as % of merchandise exports) of 1962 in Singapore to that in Sweden?
Provide a short and direct response. 0.16. What is the ratio of the Exports(as % of merchandise exports) in 1963 in Singapore to that in Sweden?
Offer a very short reply. 0.13. What is the ratio of the Exports(as % of merchandise exports) of 1964 in Singapore to that in Sweden?
Provide a succinct answer. 0.11. What is the ratio of the Exports(as % of merchandise exports) of 1965 in Singapore to that in Sweden?
Ensure brevity in your answer.  0.11. What is the ratio of the Exports(as % of merchandise exports) in 1962 in Singapore to that in Switzerland?
Your answer should be very brief. 0.7. What is the ratio of the Exports(as % of merchandise exports) in 1963 in Singapore to that in Switzerland?
Offer a very short reply. 0.68. What is the ratio of the Exports(as % of merchandise exports) in 1964 in Singapore to that in Switzerland?
Provide a succinct answer. 0.54. What is the ratio of the Exports(as % of merchandise exports) of 1965 in Singapore to that in Switzerland?
Offer a terse response. 0.51. What is the ratio of the Exports(as % of merchandise exports) in 1962 in Singapore to that in Turkey?
Ensure brevity in your answer.  0.22. What is the ratio of the Exports(as % of merchandise exports) in 1963 in Singapore to that in Turkey?
Your response must be concise. 0.37. What is the ratio of the Exports(as % of merchandise exports) of 1964 in Singapore to that in Turkey?
Your response must be concise. 0.25. What is the ratio of the Exports(as % of merchandise exports) in 1965 in Singapore to that in Turkey?
Your answer should be compact. 0.2. What is the ratio of the Exports(as % of merchandise exports) of 1962 in Singapore to that in United Kingdom?
Provide a short and direct response. 0.33. What is the ratio of the Exports(as % of merchandise exports) in 1963 in Singapore to that in United Kingdom?
Your response must be concise. 0.42. What is the ratio of the Exports(as % of merchandise exports) in 1964 in Singapore to that in United Kingdom?
Keep it short and to the point. 0.36. What is the ratio of the Exports(as % of merchandise exports) in 1965 in Singapore to that in United Kingdom?
Make the answer very short. 0.35. What is the ratio of the Exports(as % of merchandise exports) in 1962 in Spain to that in Sweden?
Give a very brief answer. 0.69. What is the ratio of the Exports(as % of merchandise exports) of 1963 in Spain to that in Sweden?
Your response must be concise. 0.44. What is the ratio of the Exports(as % of merchandise exports) in 1964 in Spain to that in Sweden?
Make the answer very short. 0.42. What is the ratio of the Exports(as % of merchandise exports) in 1965 in Spain to that in Sweden?
Offer a terse response. 0.42. What is the ratio of the Exports(as % of merchandise exports) of 1962 in Spain to that in Switzerland?
Your answer should be compact. 3.01. What is the ratio of the Exports(as % of merchandise exports) in 1963 in Spain to that in Switzerland?
Keep it short and to the point. 2.33. What is the ratio of the Exports(as % of merchandise exports) in 1964 in Spain to that in Switzerland?
Provide a short and direct response. 2.07. What is the ratio of the Exports(as % of merchandise exports) in 1965 in Spain to that in Switzerland?
Offer a very short reply. 1.9. What is the ratio of the Exports(as % of merchandise exports) in 1962 in Spain to that in Turkey?
Keep it short and to the point. 0.93. What is the ratio of the Exports(as % of merchandise exports) in 1963 in Spain to that in Turkey?
Your answer should be very brief. 1.28. What is the ratio of the Exports(as % of merchandise exports) of 1964 in Spain to that in Turkey?
Your answer should be very brief. 0.95. What is the ratio of the Exports(as % of merchandise exports) in 1965 in Spain to that in Turkey?
Make the answer very short. 0.73. What is the ratio of the Exports(as % of merchandise exports) of 1962 in Spain to that in United Kingdom?
Provide a succinct answer. 1.39. What is the ratio of the Exports(as % of merchandise exports) of 1963 in Spain to that in United Kingdom?
Provide a succinct answer. 1.46. What is the ratio of the Exports(as % of merchandise exports) of 1964 in Spain to that in United Kingdom?
Your answer should be very brief. 1.39. What is the ratio of the Exports(as % of merchandise exports) of 1965 in Spain to that in United Kingdom?
Offer a very short reply. 1.29. What is the ratio of the Exports(as % of merchandise exports) of 1962 in Sweden to that in Switzerland?
Your answer should be compact. 4.38. What is the ratio of the Exports(as % of merchandise exports) of 1963 in Sweden to that in Switzerland?
Your answer should be very brief. 5.29. What is the ratio of the Exports(as % of merchandise exports) of 1964 in Sweden to that in Switzerland?
Your answer should be very brief. 4.87. What is the ratio of the Exports(as % of merchandise exports) of 1965 in Sweden to that in Switzerland?
Your answer should be compact. 4.56. What is the ratio of the Exports(as % of merchandise exports) of 1962 in Sweden to that in Turkey?
Offer a terse response. 1.35. What is the ratio of the Exports(as % of merchandise exports) in 1963 in Sweden to that in Turkey?
Your answer should be compact. 2.9. What is the ratio of the Exports(as % of merchandise exports) of 1964 in Sweden to that in Turkey?
Provide a succinct answer. 2.24. What is the ratio of the Exports(as % of merchandise exports) in 1965 in Sweden to that in Turkey?
Provide a short and direct response. 1.75. What is the ratio of the Exports(as % of merchandise exports) in 1962 in Sweden to that in United Kingdom?
Provide a succinct answer. 2.02. What is the ratio of the Exports(as % of merchandise exports) in 1963 in Sweden to that in United Kingdom?
Offer a very short reply. 3.31. What is the ratio of the Exports(as % of merchandise exports) in 1964 in Sweden to that in United Kingdom?
Your answer should be compact. 3.28. What is the ratio of the Exports(as % of merchandise exports) of 1965 in Sweden to that in United Kingdom?
Keep it short and to the point. 3.1. What is the ratio of the Exports(as % of merchandise exports) in 1962 in Switzerland to that in Turkey?
Your answer should be compact. 0.31. What is the ratio of the Exports(as % of merchandise exports) in 1963 in Switzerland to that in Turkey?
Keep it short and to the point. 0.55. What is the ratio of the Exports(as % of merchandise exports) of 1964 in Switzerland to that in Turkey?
Offer a very short reply. 0.46. What is the ratio of the Exports(as % of merchandise exports) in 1965 in Switzerland to that in Turkey?
Offer a very short reply. 0.38. What is the ratio of the Exports(as % of merchandise exports) of 1962 in Switzerland to that in United Kingdom?
Your answer should be compact. 0.46. What is the ratio of the Exports(as % of merchandise exports) in 1963 in Switzerland to that in United Kingdom?
Ensure brevity in your answer.  0.63. What is the ratio of the Exports(as % of merchandise exports) of 1964 in Switzerland to that in United Kingdom?
Provide a succinct answer. 0.67. What is the ratio of the Exports(as % of merchandise exports) in 1965 in Switzerland to that in United Kingdom?
Ensure brevity in your answer.  0.68. What is the ratio of the Exports(as % of merchandise exports) in 1962 in Turkey to that in United Kingdom?
Your answer should be very brief. 1.5. What is the ratio of the Exports(as % of merchandise exports) of 1963 in Turkey to that in United Kingdom?
Keep it short and to the point. 1.14. What is the ratio of the Exports(as % of merchandise exports) in 1964 in Turkey to that in United Kingdom?
Ensure brevity in your answer.  1.46. What is the ratio of the Exports(as % of merchandise exports) in 1965 in Turkey to that in United Kingdom?
Keep it short and to the point. 1.77. What is the difference between the highest and the second highest Exports(as % of merchandise exports) of 1962?
Make the answer very short. 2.32. What is the difference between the highest and the second highest Exports(as % of merchandise exports) of 1963?
Provide a succinct answer. 7.2. What is the difference between the highest and the second highest Exports(as % of merchandise exports) in 1964?
Give a very brief answer. 7.33. What is the difference between the highest and the second highest Exports(as % of merchandise exports) in 1965?
Ensure brevity in your answer.  5.72. What is the difference between the highest and the lowest Exports(as % of merchandise exports) of 1962?
Offer a terse response. 7.47. What is the difference between the highest and the lowest Exports(as % of merchandise exports) in 1963?
Give a very brief answer. 11.22. What is the difference between the highest and the lowest Exports(as % of merchandise exports) of 1964?
Give a very brief answer. 11.78. What is the difference between the highest and the lowest Exports(as % of merchandise exports) in 1965?
Provide a succinct answer. 11.83. 